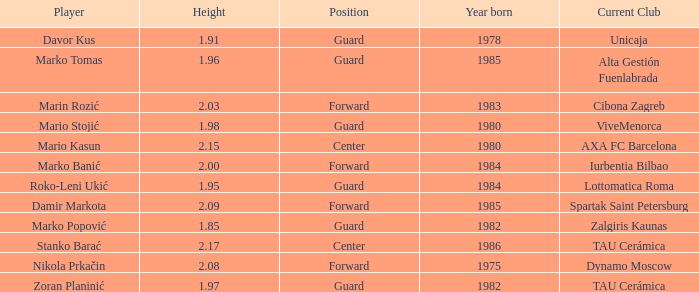What is the height of the player who currently plays for Alta Gestión Fuenlabrada? 1.96. 